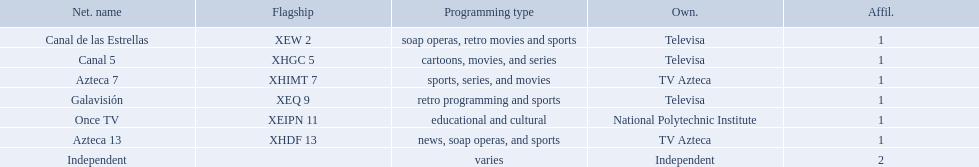What are each of the networks? Canal de las Estrellas, Canal 5, Azteca 7, Galavisión, Once TV, Azteca 13, Independent. Who owns them? Televisa, Televisa, TV Azteca, Televisa, National Polytechnic Institute, TV Azteca, Independent. Which networks aren't owned by televisa? Azteca 7, Once TV, Azteca 13, Independent. What type of programming do those networks offer? Sports, series, and movies, educational and cultural, news, soap operas, and sports, varies. Would you mind parsing the complete table? {'header': ['Net. name', 'Flagship', 'Programming type', 'Own.', 'Affil.'], 'rows': [['Canal de las Estrellas', 'XEW 2', 'soap operas, retro movies and sports', 'Televisa', '1'], ['Canal 5', 'XHGC 5', 'cartoons, movies, and series', 'Televisa', '1'], ['Azteca 7', 'XHIMT 7', 'sports, series, and movies', 'TV Azteca', '1'], ['Galavisión', 'XEQ 9', 'retro programming and sports', 'Televisa', '1'], ['Once TV', 'XEIPN 11', 'educational and cultural', 'National Polytechnic Institute', '1'], ['Azteca 13', 'XHDF 13', 'news, soap operas, and sports', 'TV Azteca', '1'], ['Independent', '', 'varies', 'Independent', '2']]} And which network is the only one with sports? Azteca 7. What stations show sports? Soap operas, retro movies and sports, retro programming and sports, news, soap operas, and sports. What of these is not affiliated with televisa? Azteca 7. I'm looking to parse the entire table for insights. Could you assist me with that? {'header': ['Net. name', 'Flagship', 'Programming type', 'Own.', 'Affil.'], 'rows': [['Canal de las Estrellas', 'XEW 2', 'soap operas, retro movies and sports', 'Televisa', '1'], ['Canal 5', 'XHGC 5', 'cartoons, movies, and series', 'Televisa', '1'], ['Azteca 7', 'XHIMT 7', 'sports, series, and movies', 'TV Azteca', '1'], ['Galavisión', 'XEQ 9', 'retro programming and sports', 'Televisa', '1'], ['Once TV', 'XEIPN 11', 'educational and cultural', 'National Polytechnic Institute', '1'], ['Azteca 13', 'XHDF 13', 'news, soap operas, and sports', 'TV Azteca', '1'], ['Independent', '', 'varies', 'Independent', '2']]} What television stations are in morelos? Canal de las Estrellas, Canal 5, Azteca 7, Galavisión, Once TV, Azteca 13, Independent. Of those which network is owned by national polytechnic institute? Once TV. 